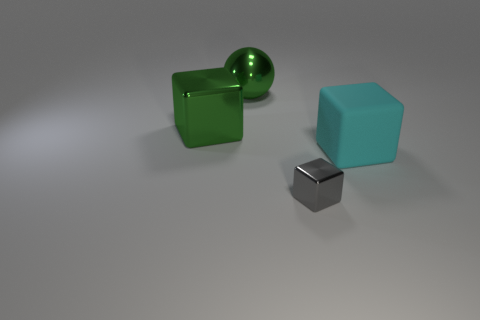If this scene were part of a larger story, what role do you think these objects might play? In a larger narrative, these objects could serve as symbolic elements or props within a minimalist setting. The metallic block might represent technology or the future, while the colored cubes could symbolize structure and order, or perhaps they're puzzle pieces in a game or challenge the characters must solve. 